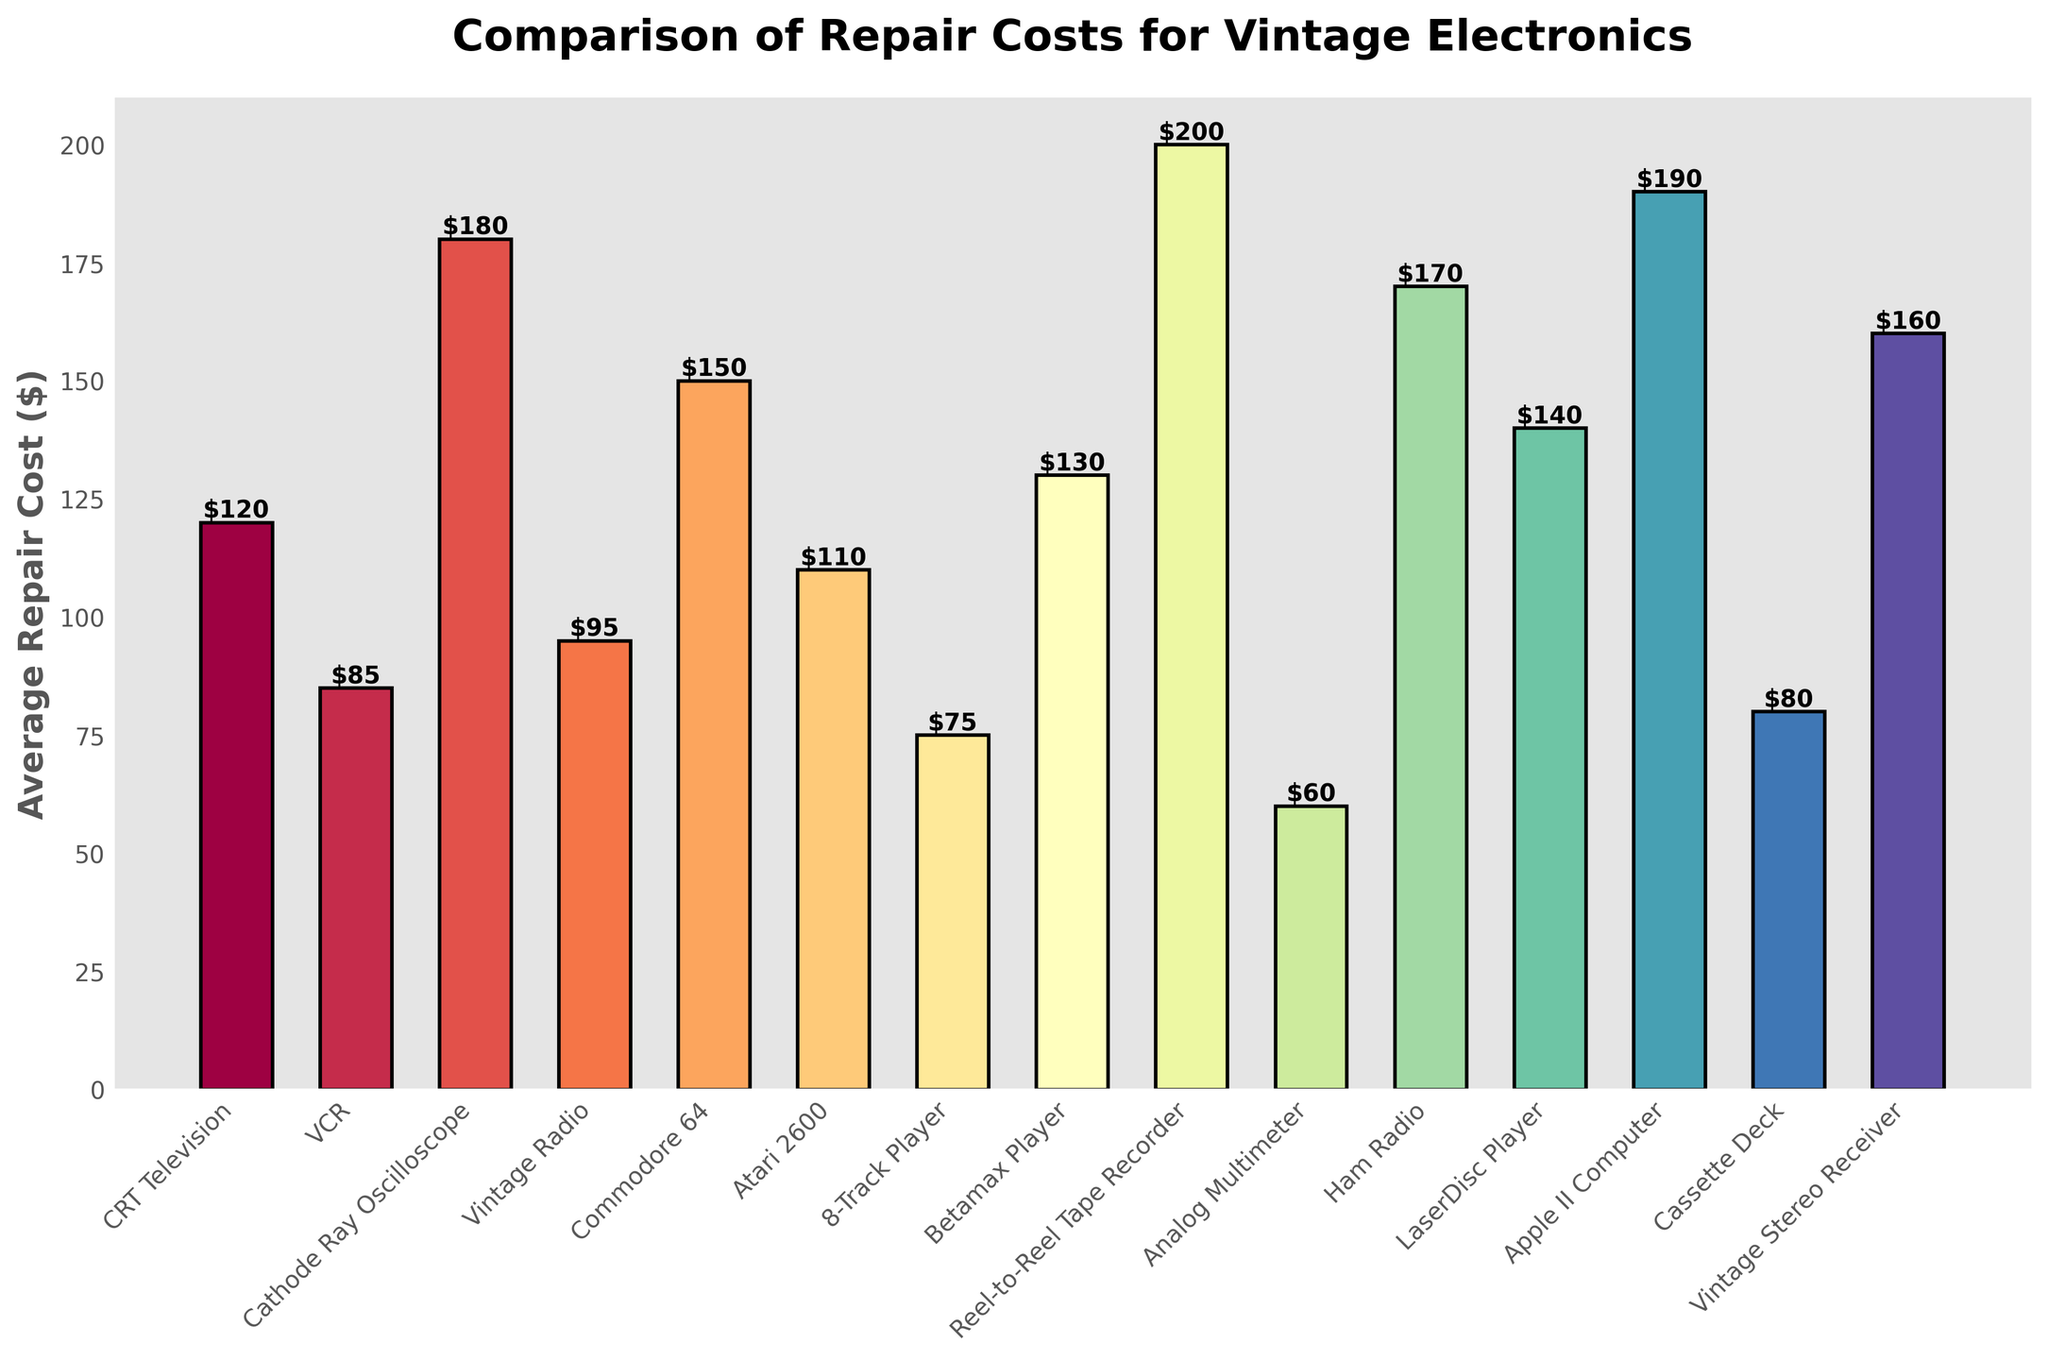what is the average repair cost for the Commodore 64 and the Atari 2600 combined? To find the average repair cost for both pieces of equipment, sum their individual costs and then divide by 2. Commodore 64 costs $150, and Atari 2600 costs $110. So, (150+110)/2 = 130.
Answer: 130 Which type of electronic equipment has the highest repair cost? By looking visually at the heights of the bars, the reel-to-reel tape recorder has the highest bar, indicating it has the highest repair cost.
Answer: Reel-to-Reel Tape Recorder Which equipment type has a lower repair cost, the Betamax Player or the VCR? Compare the heights of the bars for the Betamax Player and the VCR. The VCR has a repair cost of $85, while the Betamax Player is $130, so the VCR has the lower cost.
Answer: VCR What is the total repair cost if you own a CRT television, a vintage radio, and a cassette deck? Sum the repair costs of these three items: CRT Television ($120) + Vintage Radio ($95) + Cassette Deck ($80) = 295.
Answer: 295 Between the LaserDisc Player and the Apple II Computer, which one has the higher repair cost and by how much? Subtract the cost of the LaserDisc Player from the cost of the Apple II Computer. Apple II Computer ($190) - LaserDisc Player ($140) = 50, so the Apple II Computer’s repair cost is higher by $50
Answer: Apple II Computer, by $50 Which equipment type has the lowest repair cost? Visually identify the shortest bar on the chart, which corresponds to the Analog Multimeter with a repair cost of $60.
Answer: Analog Multimeter If you want to repair both a Commodore 64 and a Ham Radio, how much will it cost in total? Sum the repair costs of the Commodore 64 and the Ham Radio. Commodore 64 ($150) + Ham Radio ($170) = 320.
Answer: 320 What is the difference in repair cost between a vintage stereo receiver and an 8-track player? Subtract the cost of the 8-Track Player from the cost of the Vintage Stereo Receiver. Vintage Stereo Receiver ($160) - 8-Track Player ($75) = 85.
Answer: 85 What is the average repair cost among all the equipment types shown on the chart? Sum all the repair costs shown and then divide by the number of equipment types. Sum = 120+85+180+95+150+110+75+130+200+60+170+140+190+80+160 = 1945. Number of equipment types = 15. So, 1945/15 = 129.67
Answer: 129.67 